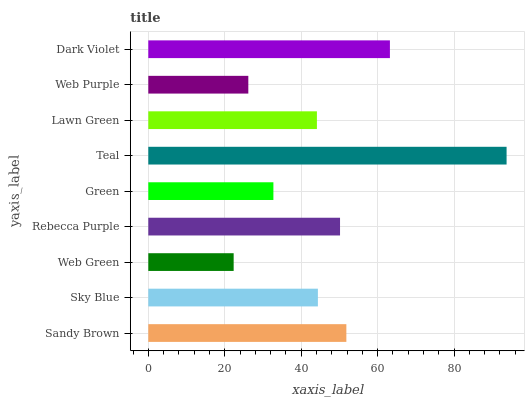Is Web Green the minimum?
Answer yes or no. Yes. Is Teal the maximum?
Answer yes or no. Yes. Is Sky Blue the minimum?
Answer yes or no. No. Is Sky Blue the maximum?
Answer yes or no. No. Is Sandy Brown greater than Sky Blue?
Answer yes or no. Yes. Is Sky Blue less than Sandy Brown?
Answer yes or no. Yes. Is Sky Blue greater than Sandy Brown?
Answer yes or no. No. Is Sandy Brown less than Sky Blue?
Answer yes or no. No. Is Sky Blue the high median?
Answer yes or no. Yes. Is Sky Blue the low median?
Answer yes or no. Yes. Is Web Purple the high median?
Answer yes or no. No. Is Rebecca Purple the low median?
Answer yes or no. No. 